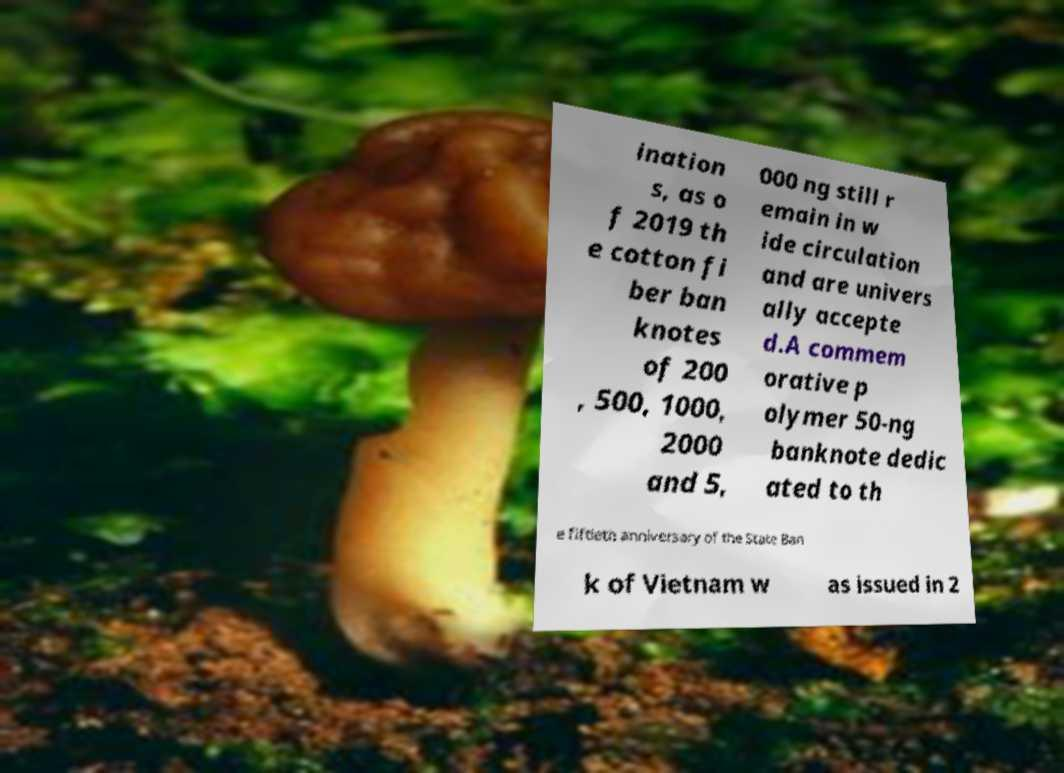Please read and relay the text visible in this image. What does it say? ination s, as o f 2019 th e cotton fi ber ban knotes of 200 , 500, 1000, 2000 and 5, 000 ng still r emain in w ide circulation and are univers ally accepte d.A commem orative p olymer 50-ng banknote dedic ated to th e fiftieth anniversary of the State Ban k of Vietnam w as issued in 2 